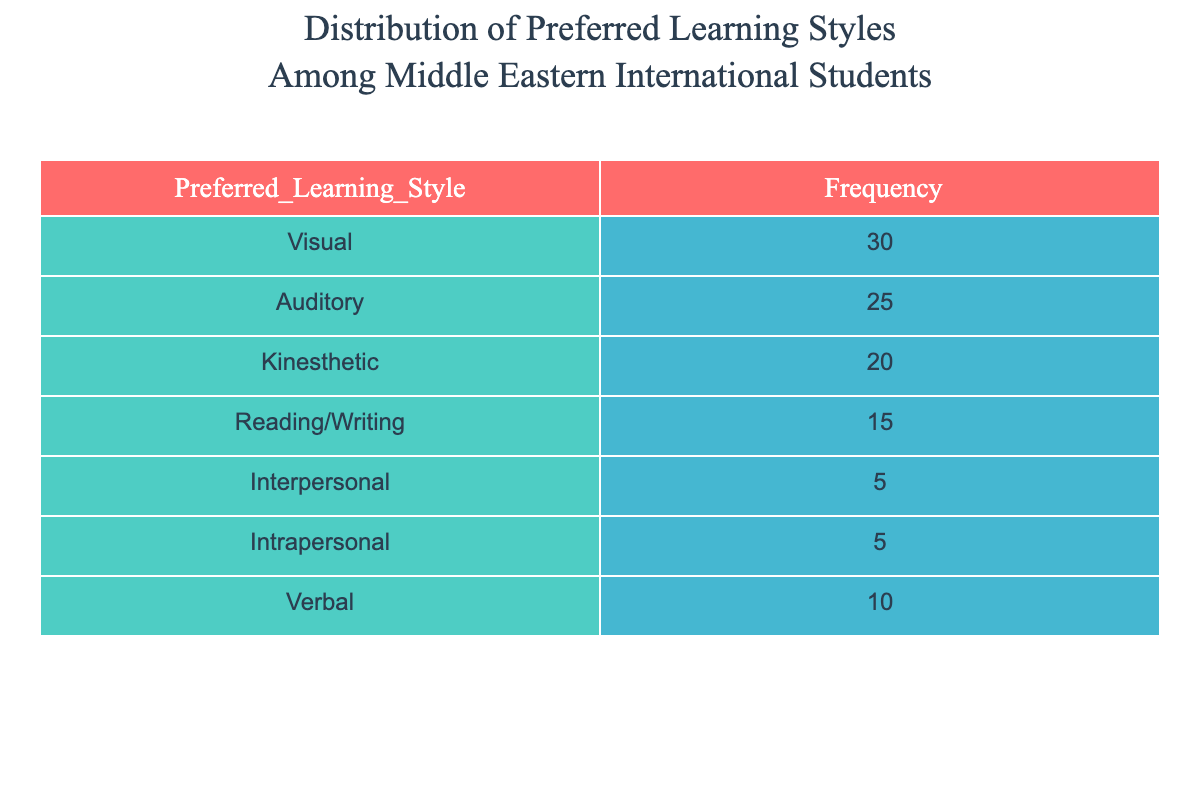What is the frequency of the Visual learning style? According to the table, the frequency listed for the Visual learning style is 30.
Answer: 30 Which learning style has the lowest frequency? Upon examining the table, both Interpersonal and Intrapersonal learning styles have the lowest frequency, each at 5.
Answer: Interpersonal and Intrapersonal What is the total frequency of preferred learning styles? To find the total frequency, add up all the individual frequencies: 30 + 25 + 20 + 15 + 5 + 5 + 10 = 110.
Answer: 110 What is the difference in frequency between Auditory and Kinesthetic learning styles? By looking at the frequencies, Auditory has a frequency of 25 and Kinesthetic has a frequency of 20. The difference is 25 - 20 = 5.
Answer: 5 Is the frequency of Reading/Writing higher than that of Verbal? Reading/Writing has a frequency of 15, while Verbal has a frequency of 10. Since 15 is greater than 10, the statement is true.
Answer: Yes Which learning style(s) have frequencies that are greater than the average frequency of all learning styles? First, calculate the average frequency: 110 total frequency / 7 learning styles = 15.71 (rounded to two decimal places). Then, compare each style's frequency to this average; Visual, Auditory, and Kinesthetic have frequencies higher than the average (30, 25, and 20, respectively).
Answer: Visual, Auditory, Kinesthetic What percentage of students prefer Kinesthetic learning style? To find the percentage, divide the frequency of Kinesthetic (20) by the total frequency (110), then multiply by 100: (20/110) x 100 = 18.18%.
Answer: 18.18% What is the combined frequency of the Interpersonal and Intrapersonal learning styles? The frequency of Interpersonal is 5 and Intrapersonal is also 5. Add these together: 5 + 5 = 10.
Answer: 10 Which learning style has more than 20 students preferring it? From the table, Visual (30) and Auditory (25) have frequencies over 20.
Answer: Visual, Auditory 